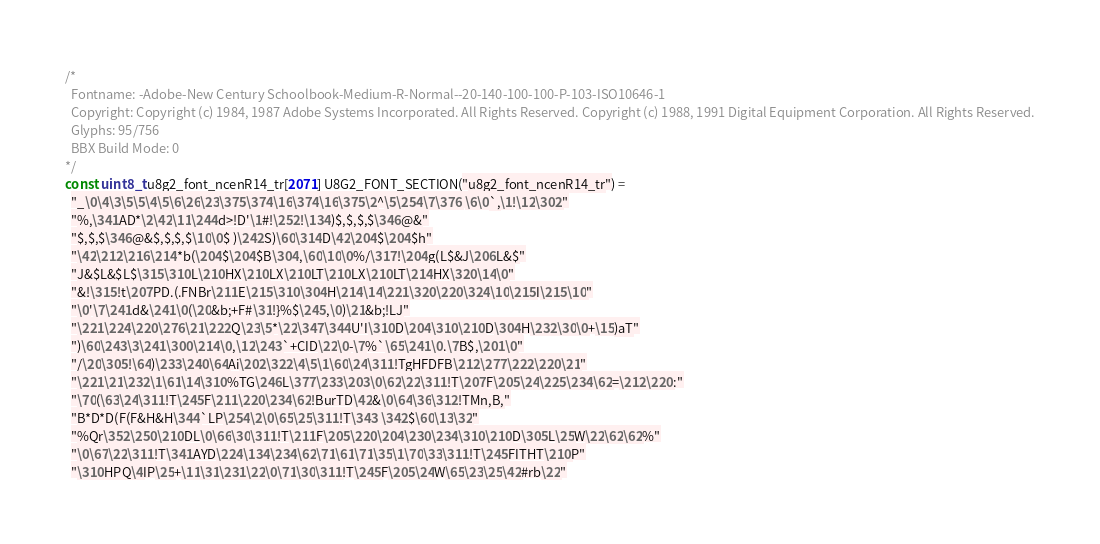Convert code to text. <code><loc_0><loc_0><loc_500><loc_500><_C_>/*
  Fontname: -Adobe-New Century Schoolbook-Medium-R-Normal--20-140-100-100-P-103-ISO10646-1
  Copyright: Copyright (c) 1984, 1987 Adobe Systems Incorporated. All Rights Reserved. Copyright (c) 1988, 1991 Digital Equipment Corporation. All Rights Reserved.
  Glyphs: 95/756
  BBX Build Mode: 0
*/
const uint8_t u8g2_font_ncenR14_tr[2071] U8G2_FONT_SECTION("u8g2_font_ncenR14_tr") = 
  "_\0\4\3\5\5\4\5\6\26\23\375\374\16\374\16\375\2^\5\254\7\376 \6\0`,\1!\12\302"
  "%,\341AD*\2\42\11\244d>!D'\1#!\252!\134)$,$,$,$\346@&"
  "$,$,$\346@&$,$,$,$\10\0$ )\242S)\60\314D\42\204$\204$h"
  "\42\212\216\214*b(\204$\204$B\304,\60\10\0%/\317!\204g(L$&J\206L&$"
  "J&$L&$L$\315\310L\210HX\210LX\210LT\210LX\210LT\214HX\320\14\0"
  "&!\315!t\207PD.(.FNBr\211E\215\310\304H\214\14\221\320\220\324\10\215I\215\10"
  "\0'\7\241d&\241\0(\20&b;+F#\31!}%$\245,\0)\21&b;!LJ"
  "\221\224\220\276\21\222Q\23\5*\22\347\344U'I\310D\204\310\210D\304H\232\30\0+\15)aT"
  ")\60\243\3\241\300\214\0,\12\243`+CID\22\0-\7%`\65\241\0.\7B$,\201\0"
  "/\20\305!\64)\233\240\64Ai\202\322\4\5\1\60\24\311!TgHFDFB\212\277\222\220\21"
  "\221\21\232\1\61\14\310%TG\246L\377\233\203\0\62\22\311!T\207F\205\24\225\234\62=\212\220:"
  "\70(\63\24\311!T\245F\211\220\234\62!BurTD\42&\0\64\36\312!TMn,B,"
  "B*D*D(F(F&H&H\344`LP\254\2\0\65\25\311!T\343 \342$\60\13\32"
  "%Qr\352\250\210DL\0\66\30\311!T\211F\205\220\204\230\234\310\210D\305L\25W\22\62\62%"
  "\0\67\22\311!T\341AYD\224\134\234\62\71\61\71\35\1\70\33\311!T\245FITHT\210P"
  "\310HPQ\4IP\25+\11\31\231\22\0\71\30\311!T\245F\205\24W\65\23\25\42#rb\22"</code> 